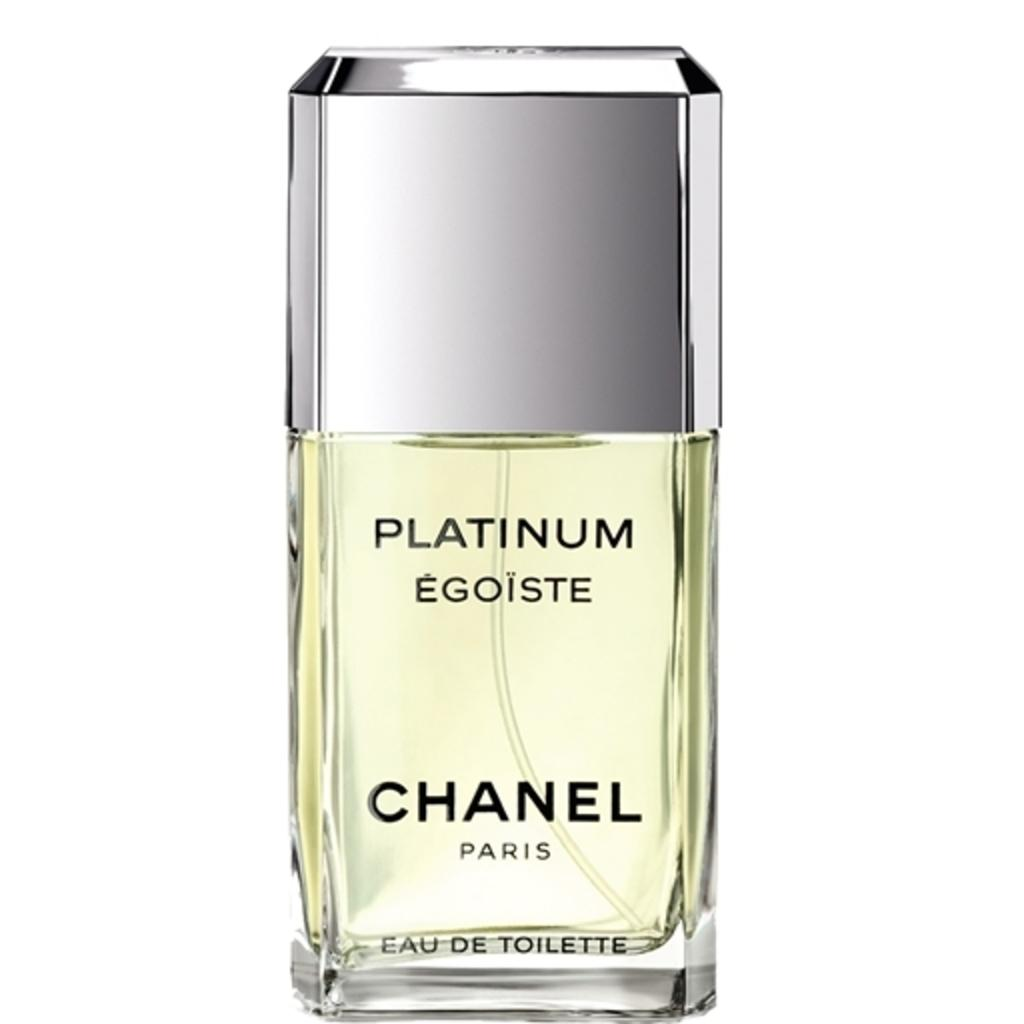<image>
Render a clear and concise summary of the photo. some chanel cologne with some platinum in it 